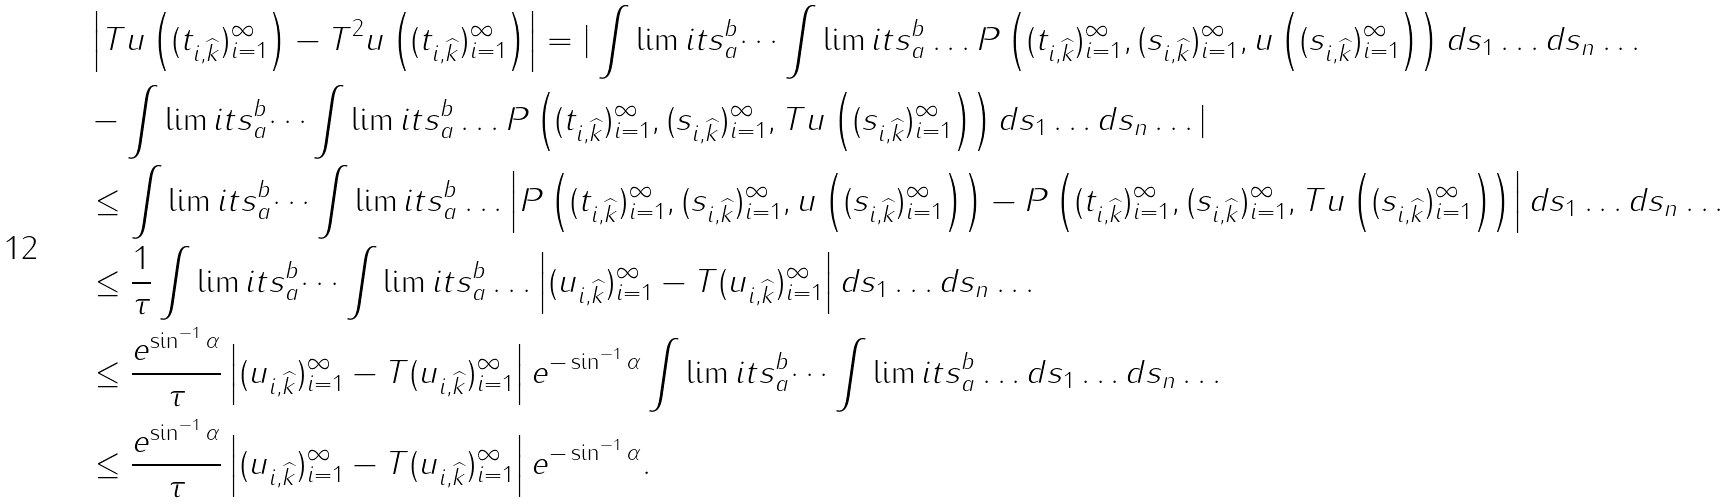Convert formula to latex. <formula><loc_0><loc_0><loc_500><loc_500>& \left | T u \left ( ( t _ { i , \widehat { k } } ) _ { i = 1 } ^ { \infty } \right ) - T ^ { 2 } u \left ( ( t _ { i , \widehat { k } } ) _ { i = 1 } ^ { \infty } \right ) \right | = | \int \lim i t s _ { a } ^ { b } \dots \int \lim i t s _ { a } ^ { b } \dots P \left ( ( t _ { i , \widehat { k } } ) _ { i = 1 } ^ { \infty } , ( s _ { i , \widehat { k } } ) _ { i = 1 } ^ { \infty } , u \left ( ( s _ { i , \widehat { k } } ) _ { i = 1 } ^ { \infty } \right ) \right ) d s _ { 1 } \dots d s _ { n } \dots \\ & - \int \lim i t s _ { a } ^ { b } \dots \int \lim i t s _ { a } ^ { b } \dots P \left ( ( t _ { i , \widehat { k } } ) _ { i = 1 } ^ { \infty } , ( s _ { i , \widehat { k } } ) _ { i = 1 } ^ { \infty } , T u \left ( ( s _ { i , \widehat { k } } ) _ { i = 1 } ^ { \infty } \right ) \right ) d s _ { 1 } \dots d s _ { n } \dots | \\ & \leq \int \lim i t s _ { a } ^ { b } \dots \int \lim i t s _ { a } ^ { b } \dots \left | P \left ( ( t _ { i , \widehat { k } } ) _ { i = 1 } ^ { \infty } , ( s _ { i , \widehat { k } } ) _ { i = 1 } ^ { \infty } , u \left ( ( s _ { i , \widehat { k } } ) _ { i = 1 } ^ { \infty } \right ) \right ) - P \left ( ( t _ { i , \widehat { k } } ) _ { i = 1 } ^ { \infty } , ( s _ { i , \widehat { k } } ) _ { i = 1 } ^ { \infty } , T u \left ( ( s _ { i , \widehat { k } } ) _ { i = 1 } ^ { \infty } \right ) \right ) \right | d s _ { 1 } \dots d s _ { n } \dots \\ & \leq \frac { 1 } { \tau } \int \lim i t s _ { a } ^ { b } \dots \int \lim i t s _ { a } ^ { b } \dots \left | ( u _ { i , \widehat { k } } ) _ { i = 1 } ^ { \infty } - T ( u _ { i , \widehat { k } } ) _ { i = 1 } ^ { \infty } \right | d s _ { 1 } \dots d s _ { n } \dots \\ & \leq \frac { e ^ { \sin ^ { - 1 } \alpha } } { \tau } \left | ( u _ { i , \widehat { k } } ) _ { i = 1 } ^ { \infty } - T ( u _ { i , \widehat { k } } ) _ { i = 1 } ^ { \infty } \right | e ^ { - \sin ^ { - 1 } \alpha } \int \lim i t s _ { a } ^ { b } \dots \int \lim i t s _ { a } ^ { b } \dots d s _ { 1 } \dots d s _ { n } \dots \\ & \leq \frac { e ^ { \sin ^ { - 1 } \alpha } } { \tau } \left | ( u _ { i , \widehat { k } } ) _ { i = 1 } ^ { \infty } - T ( u _ { i , \widehat { k } } ) _ { i = 1 } ^ { \infty } \right | e ^ { - \sin ^ { - 1 } \alpha } .</formula> 